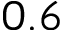Convert formula to latex. <formula><loc_0><loc_0><loc_500><loc_500>0 . 6</formula> 